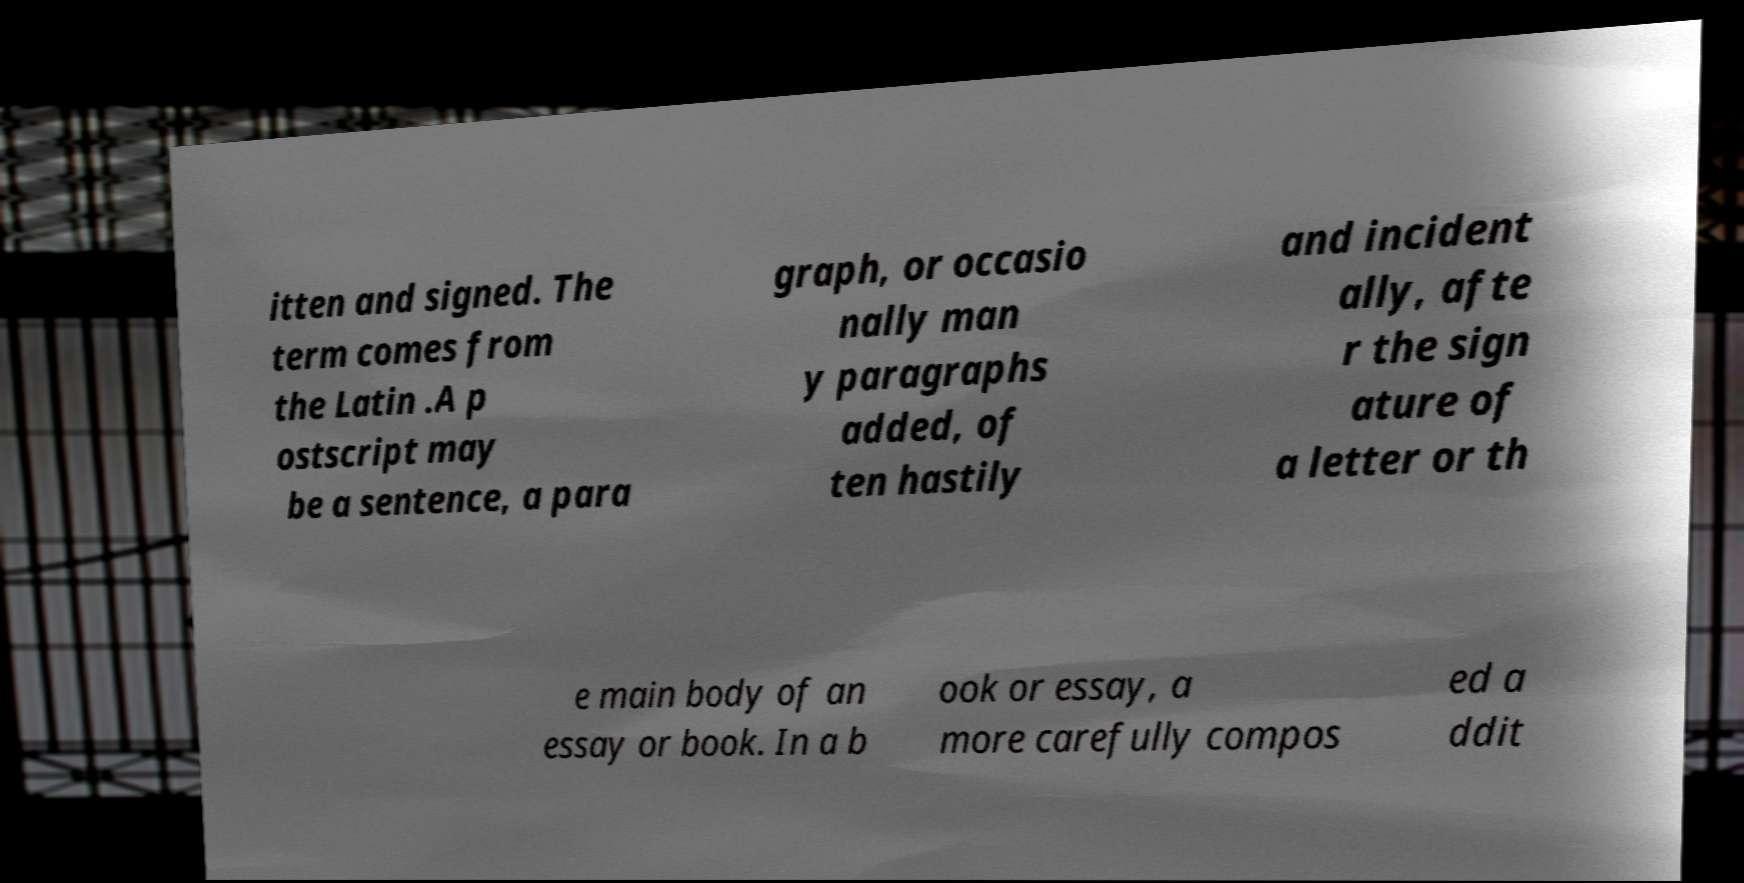Please read and relay the text visible in this image. What does it say? itten and signed. The term comes from the Latin .A p ostscript may be a sentence, a para graph, or occasio nally man y paragraphs added, of ten hastily and incident ally, afte r the sign ature of a letter or th e main body of an essay or book. In a b ook or essay, a more carefully compos ed a ddit 